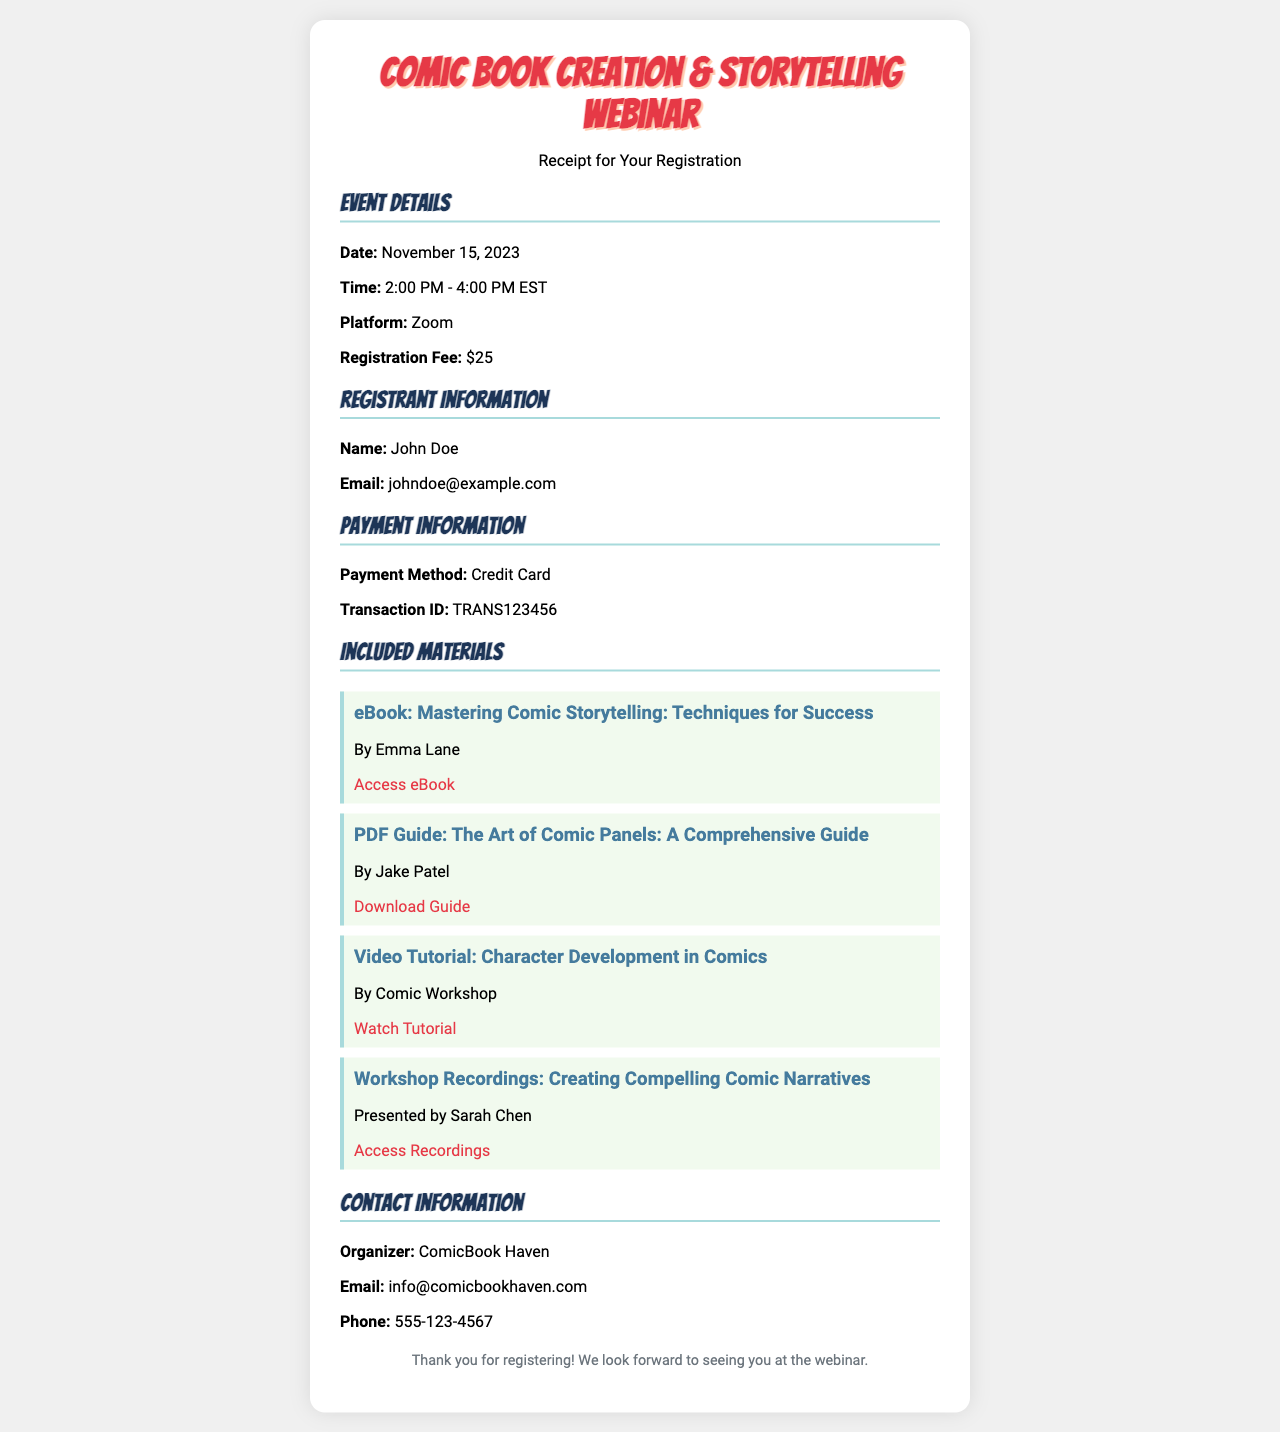What is the date of the webinar? The date of the webinar is specified in the event details section of the document.
Answer: November 15, 2023 What is the registration fee? The registration fee can be found in the event details section, detailing the cost to attend the webinar.
Answer: $25 Who is the presenter of the video tutorial? The presenter of the video tutorial is listed in the included materials section of the document.
Answer: Comic Workshop What email address should registrants contact for inquiries? The contact information section provides the email address for the organizer.
Answer: info@comicbookhaven.com What time does the webinar start? The starting time of the webinar is provided in the event details section.
Answer: 2:00 PM What is the transaction ID for the payment? The transaction ID is mentioned in the payment information section of the document.
Answer: TRANS123456 How long is the duration of the webinar? The duration of the webinar can be calculated based on the start and end times given in the event details.
Answer: 2 hours Name one type of material included with the registration. The materials section lists various materials included with registration.
Answer: eBook: Mastering Comic Storytelling: Techniques for Success What platform will the webinar be hosted on? The platform for the webinar is specified in the event details section.
Answer: Zoom 